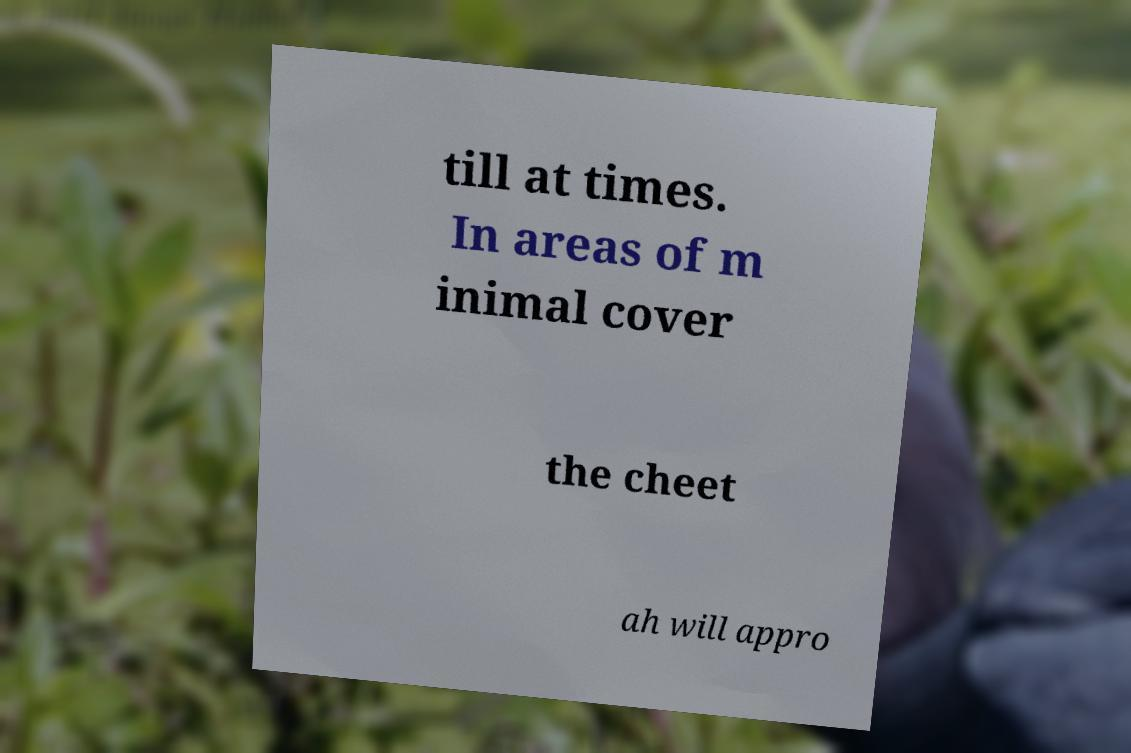Can you read and provide the text displayed in the image?This photo seems to have some interesting text. Can you extract and type it out for me? till at times. In areas of m inimal cover the cheet ah will appro 